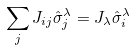<formula> <loc_0><loc_0><loc_500><loc_500>\sum _ { j } J _ { i j } \hat { \sigma } _ { j } ^ { \lambda } = J _ { \lambda } \hat { \sigma } _ { i } ^ { \lambda }</formula> 